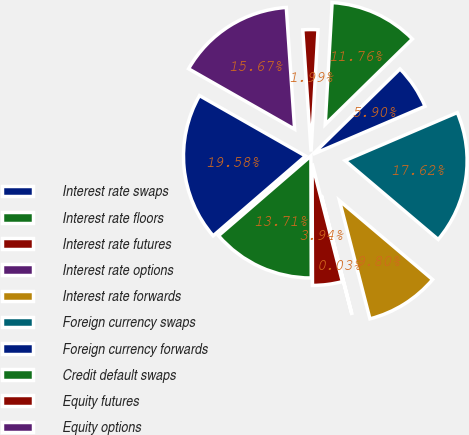<chart> <loc_0><loc_0><loc_500><loc_500><pie_chart><fcel>Interest rate swaps<fcel>Interest rate floors<fcel>Interest rate futures<fcel>Interest rate options<fcel>Interest rate forwards<fcel>Foreign currency swaps<fcel>Foreign currency forwards<fcel>Credit default swaps<fcel>Equity futures<fcel>Equity options<nl><fcel>19.58%<fcel>13.71%<fcel>3.94%<fcel>0.03%<fcel>9.8%<fcel>17.62%<fcel>5.9%<fcel>11.76%<fcel>1.99%<fcel>15.67%<nl></chart> 